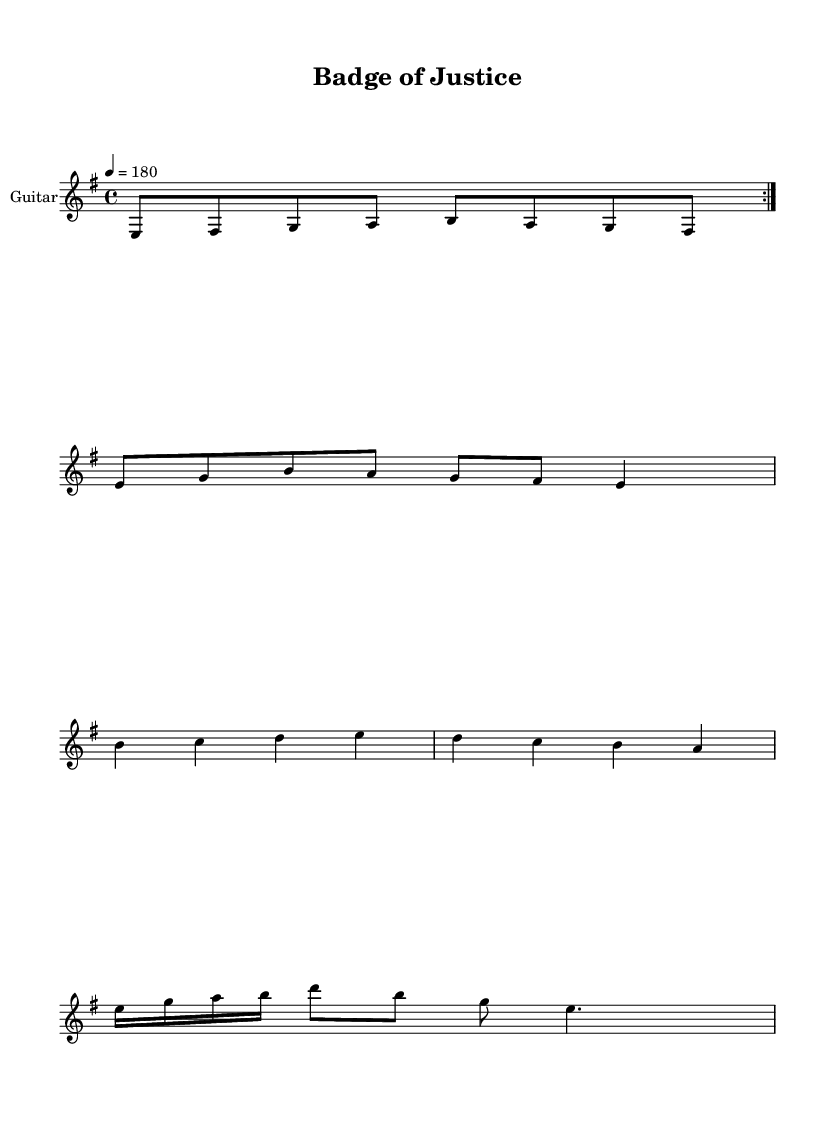What is the key signature of this music? The key signature is E minor, indicated by one sharp (F#) and the natural minor scale starting from E.
Answer: E minor What is the time signature of this piece? The time signature is 4/4, meaning there are four beats in each measure and a quarter note gets one beat.
Answer: 4/4 What is the tempo marking of this composition? The tempo marking is 180 beats per minute, indicated by the marking "4 = 180" in the tempo section.
Answer: 180 How many times is the main riff repeated? The main riff is repeated 2 times as indicated by the "repeat volta 2" marking in the notation.
Answer: 2 What themes are explored in the lyrics? The lyrics explore themes of law enforcement and crime fighting, as suggested by phrases like "Serve and protect" and "Streets of chaos."
Answer: Law enforcement, crime fighting What type of musical phrases are present in the bridge solo? The bridge solo consists of sixteenth and eighth notes followed by a dotted quarter note, creating a contrasting melodic phrase.
Answer: Sixteenth and eighth notes What does the term "Serve and protect" signify in the chorus? "Serve and protect" is a motto associated with law enforcement agencies, emphasizing their commitment to public safety and crime prevention.
Answer: Commitment to public safety 